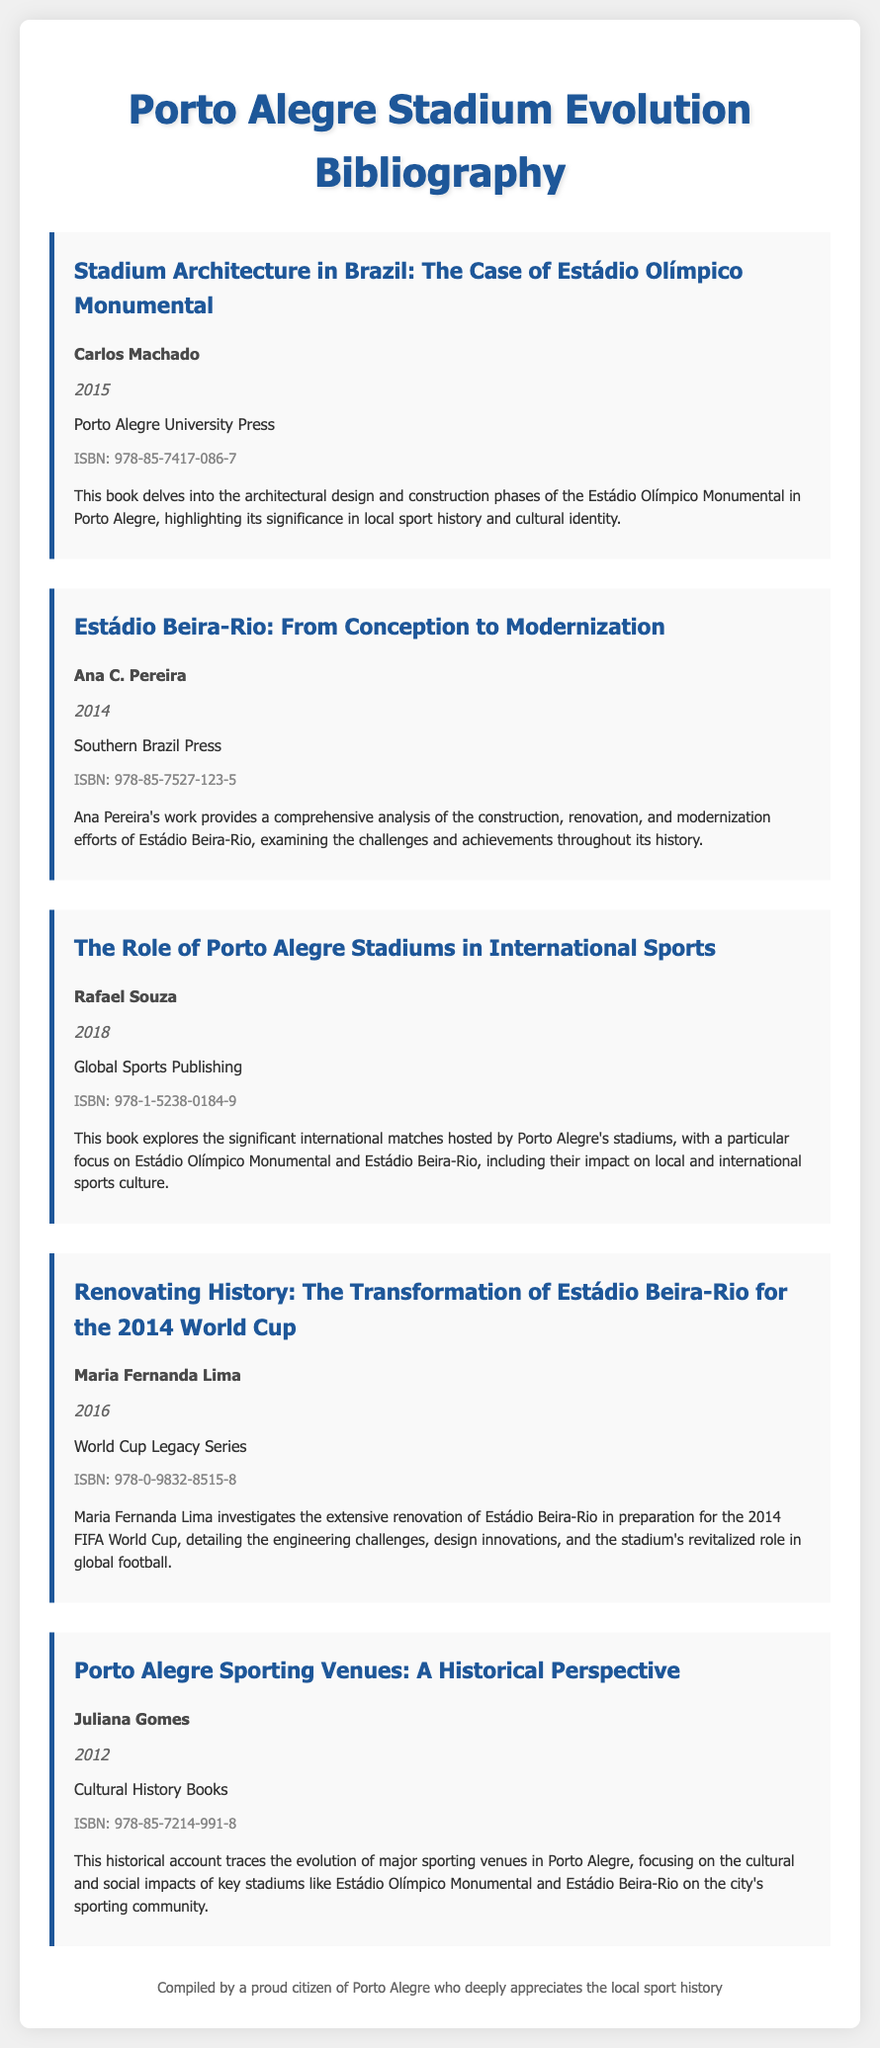What is the title of the first bibliography item? The title of the first bibliography item is "Stadium Architecture in Brazil: The Case of Estádio Olímpico Monumental."
Answer: Stadium Architecture in Brazil: The Case of Estádio Olímpico Monumental Who is the author of the book on Estádio Beira-Rio? The author of the book on Estádio Beira-Rio is Ana C. Pereira.
Answer: Ana C. Pereira What year was "Renovating History" published? "Renovating History" was published in 2016.
Answer: 2016 What is the ISBN of "The Role of Porto Alegre Stadiums in International Sports"? The ISBN of "The Role of Porto Alegre Stadiums in International Sports" is 978-1-5238-0184-9.
Answer: 978-1-5238-0184-9 Which stadium is specifically focused on in Maria Fernanda Lima's book? Maria Fernanda Lima's book specifically focuses on Estádio Beira-Rio.
Answer: Estádio Beira-Rio What cultural aspect is highlighted in the bibliography items? The cultural aspect highlighted is the stadiums' significance in local sport history and cultural identity.
Answer: Local sport history and cultural identity How many bibliography items are included in the document? There are five bibliography items included in the document.
Answer: Five What publisher released the book by Carlos Machado? The book by Carlos Machado was released by Porto Alegre University Press.
Answer: Porto Alegre University Press 